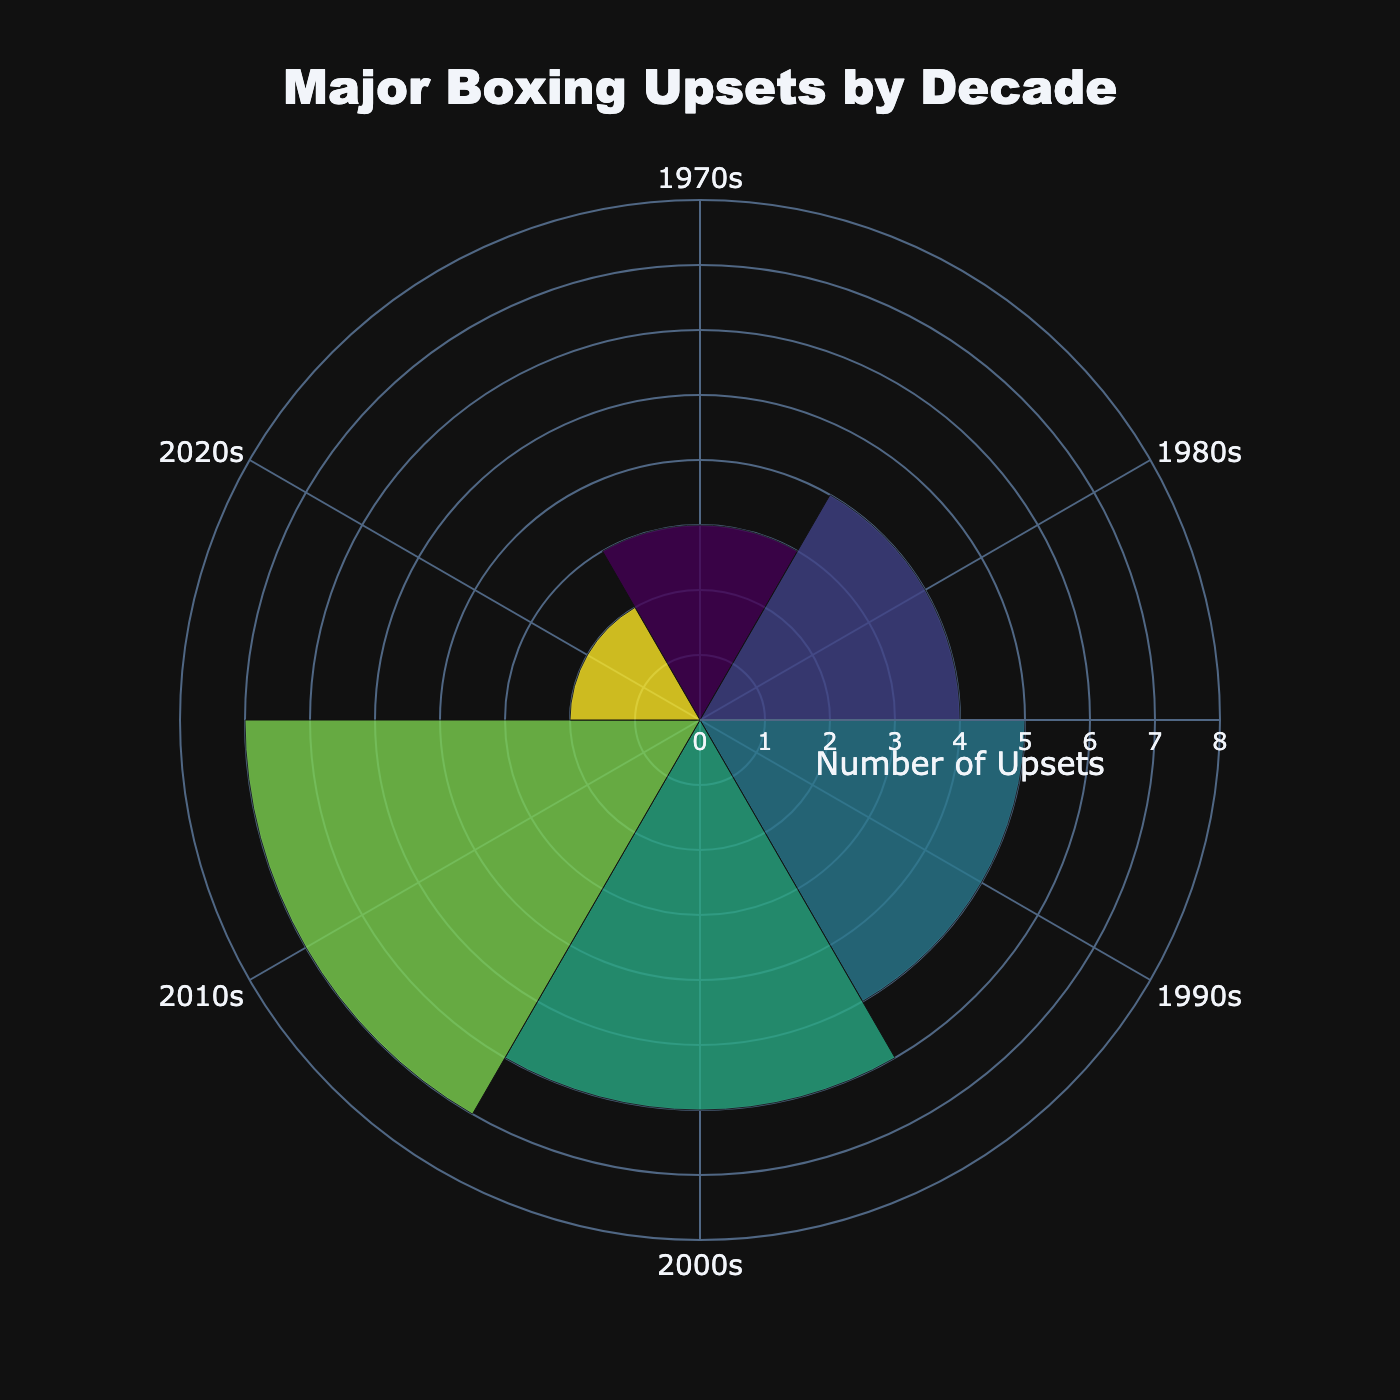What's the title of the chart? The title is usually displayed prominently at the top of the chart. In this case, it states, "Major Boxing Upsets by Decade" which provides an overview of the chart's content.
Answer: Major Boxing Upsets by Decade How many major upsets are there in the 2010s? The radial bar connected to the decade labeled "2010s" shows a length extending to the number 7, indicating the count of upsets.
Answer: 7 Which decade had the least number of major upsets? By comparing the lengths of all the radial bars, we see that the shortest bar corresponds to the decade labeled "2020s." The bar's length is 2.
Answer: 2020s What is the color scheme used in the chart? The chart employs a "Viridis" colorscale, which typically transitions from dark blue to bright yellow. This color scheme helps differentiate the bars representing each decade.
Answer: Viridis Which notable upset is associated with the 2000s? Hovering over or looking at the label of the radial bar originating from the 2000s reveals the notable upset "Lennox Lewis vs. Hasim Rahman."
Answer: Lennox Lewis vs. Hasim Rahman How many total major upsets are visualized in this chart? Summing the counts for all the decades (3 + 4 + 5 + 6 + 7 + 2) gives the total number of major upsets depicted in the chart.
Answer: 27 What's the difference between the number of major upsets in the 1980s and the 2000s? By subtracting the count of the 1980s (4) from the 2000s (6) we determine the difference.
Answer: 2 Between the 1970s and 1990s, which decade had more major upsets and by how much? By referencing the count for each decade, the 1990s had 5 upsets while the 1970s had 3. The difference is then calculated as 5 - 3.
Answer: 1990s by 2 Is the number of upsets in the 2020s closer to the number of upsets in the 1970s or the 1980s? Comparing the number of upsets in the 2020s (2) with those in the 1970s (3) and the 1980s (4), we observe that 2 is closer to 3.
Answer: 1970s Which decade had the highest number of major upsets, and what was the notable upset listed for that decade? By identifying the longest bar and corresponding labels, we see that the 2010s had the most upsets, and the notable upset was "Andy Ruiz Jr. vs. Anthony Joshua."
Answer: 2010s, Andy Ruiz Jr. vs. Anthony Joshua 